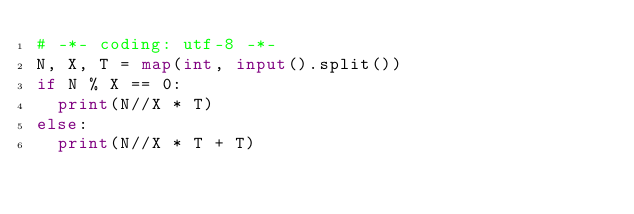Convert code to text. <code><loc_0><loc_0><loc_500><loc_500><_Python_># -*- coding: utf-8 -*-
N, X, T = map(int, input().split())
if N % X == 0:
  print(N//X * T)
else:
  print(N//X * T + T)</code> 